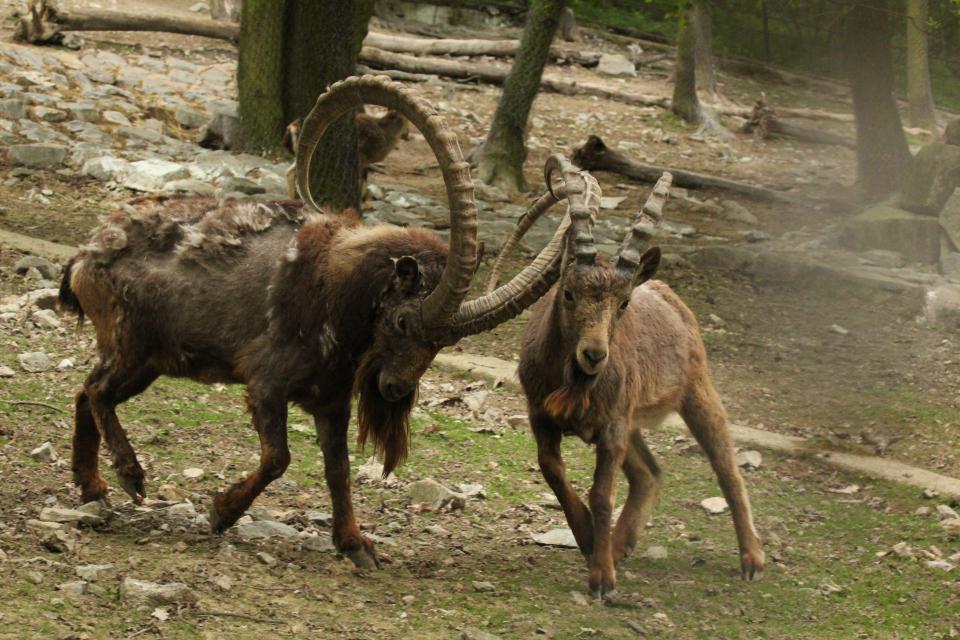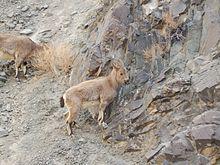The first image is the image on the left, the second image is the image on the right. For the images displayed, is the sentence "Right and left images contain the same number of hooved animals." factually correct? Answer yes or no. Yes. The first image is the image on the left, the second image is the image on the right. Given the left and right images, does the statement "The rams are walking on green grass in the image on the left." hold true? Answer yes or no. Yes. 